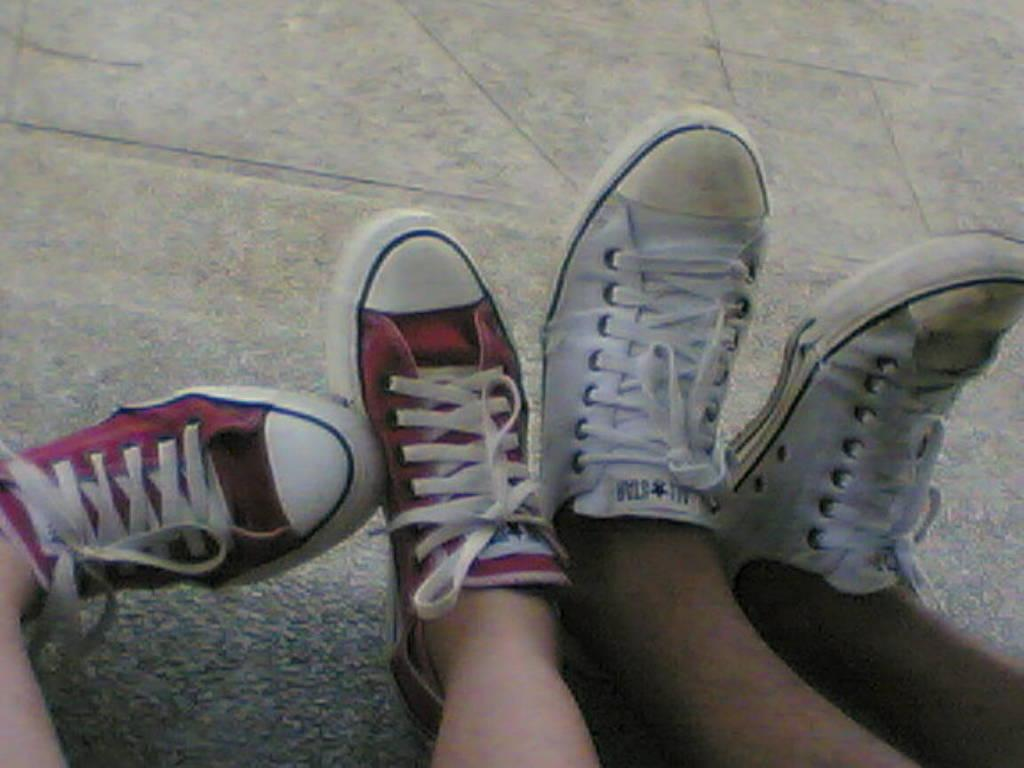How many people are in the image? There are two persons in the image. What are the people wearing on their legs? Each person has shoes on their legs. Are the shoes worn by the same person or different people? The shoes are on different persons' legs. What can be seen in the background of the image? There is a surface visible in the background of the image. What type of bat can be seen flying in the image? There is no bat present in the image; it only features two persons with shoes on their legs and a surface visible in the background. 